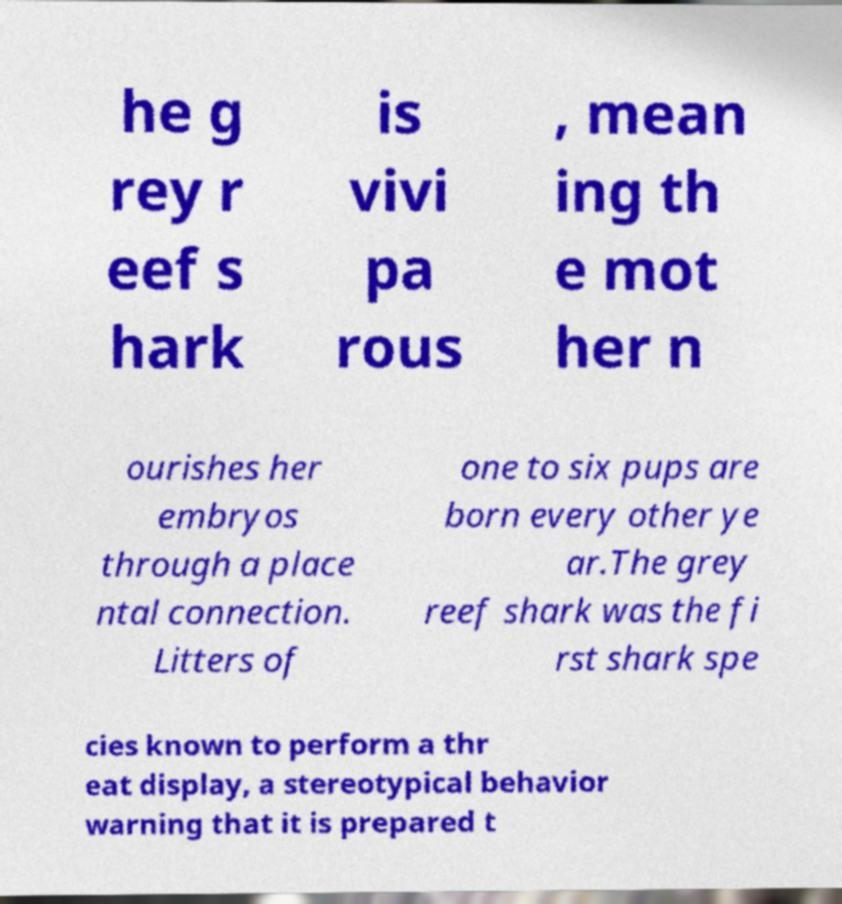Please read and relay the text visible in this image. What does it say? he g rey r eef s hark is vivi pa rous , mean ing th e mot her n ourishes her embryos through a place ntal connection. Litters of one to six pups are born every other ye ar.The grey reef shark was the fi rst shark spe cies known to perform a thr eat display, a stereotypical behavior warning that it is prepared t 